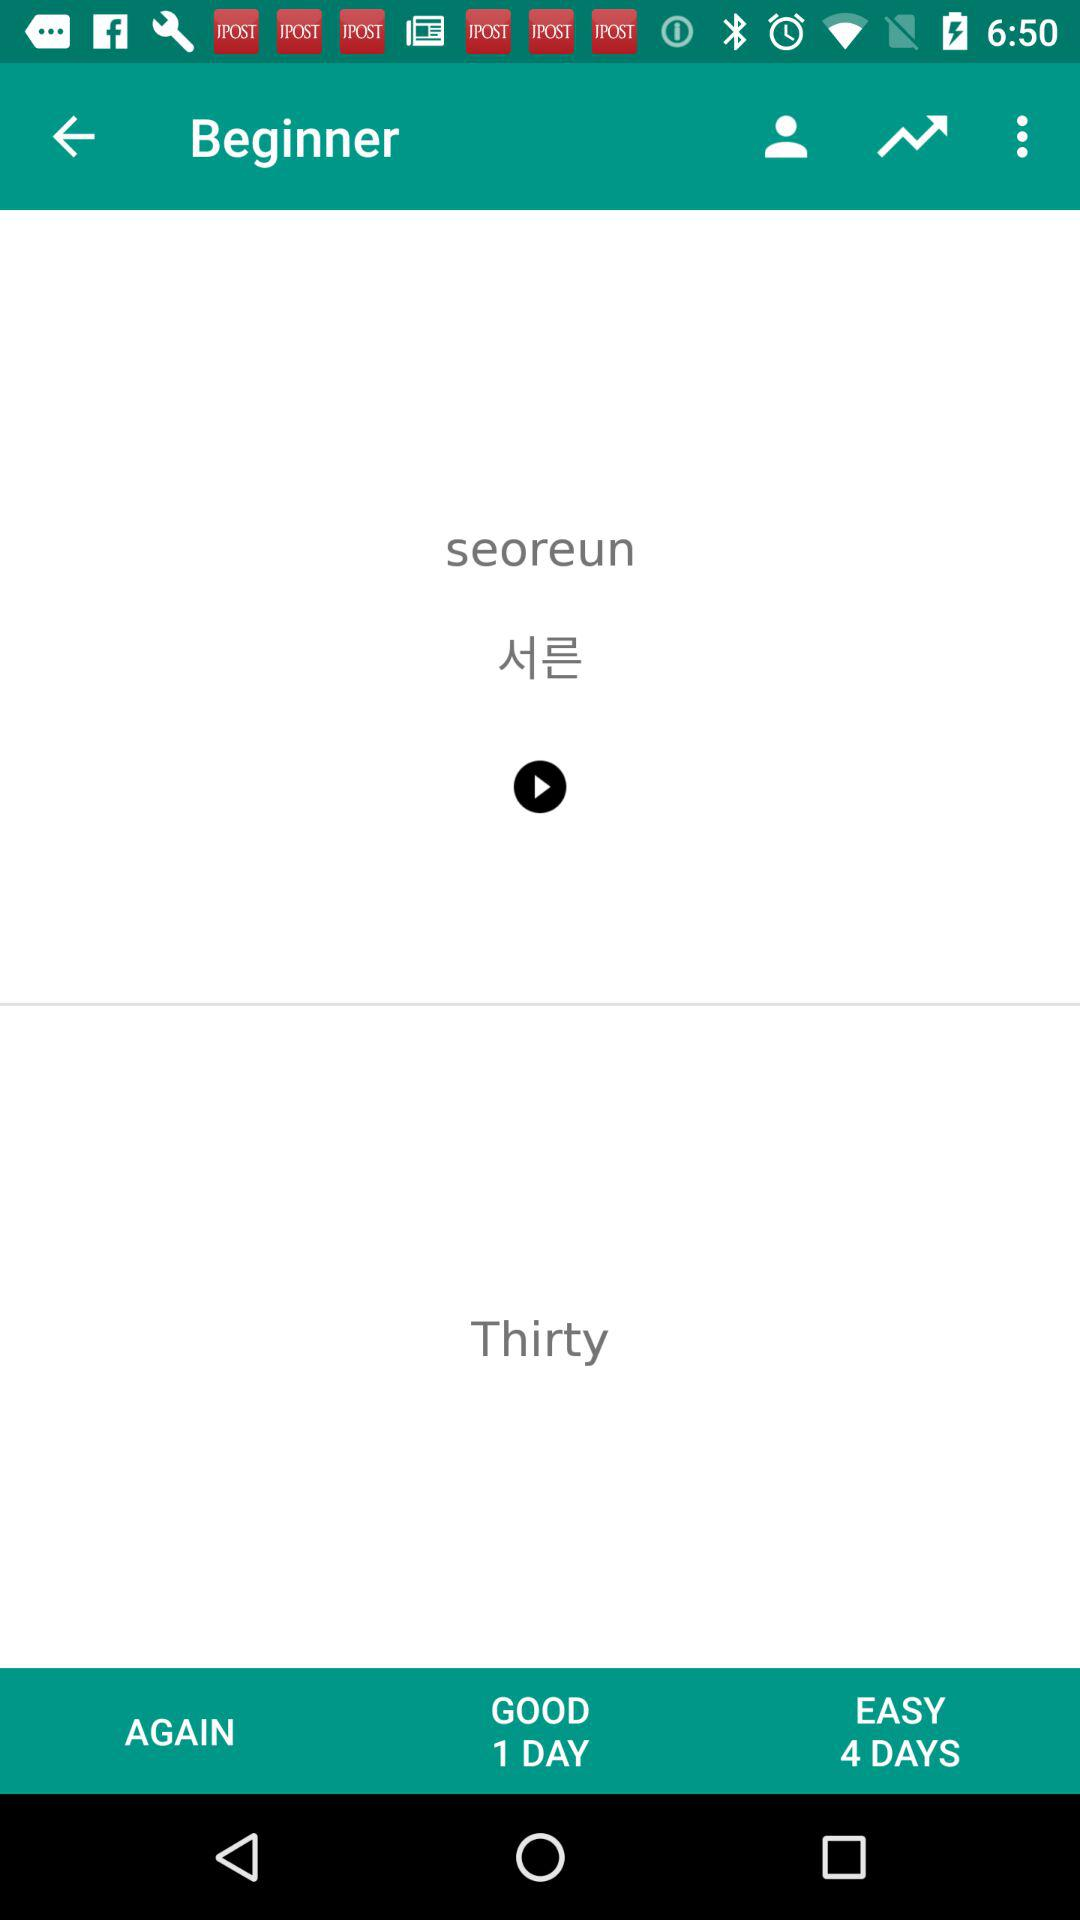How many days are easy? There are 4 easy days. 